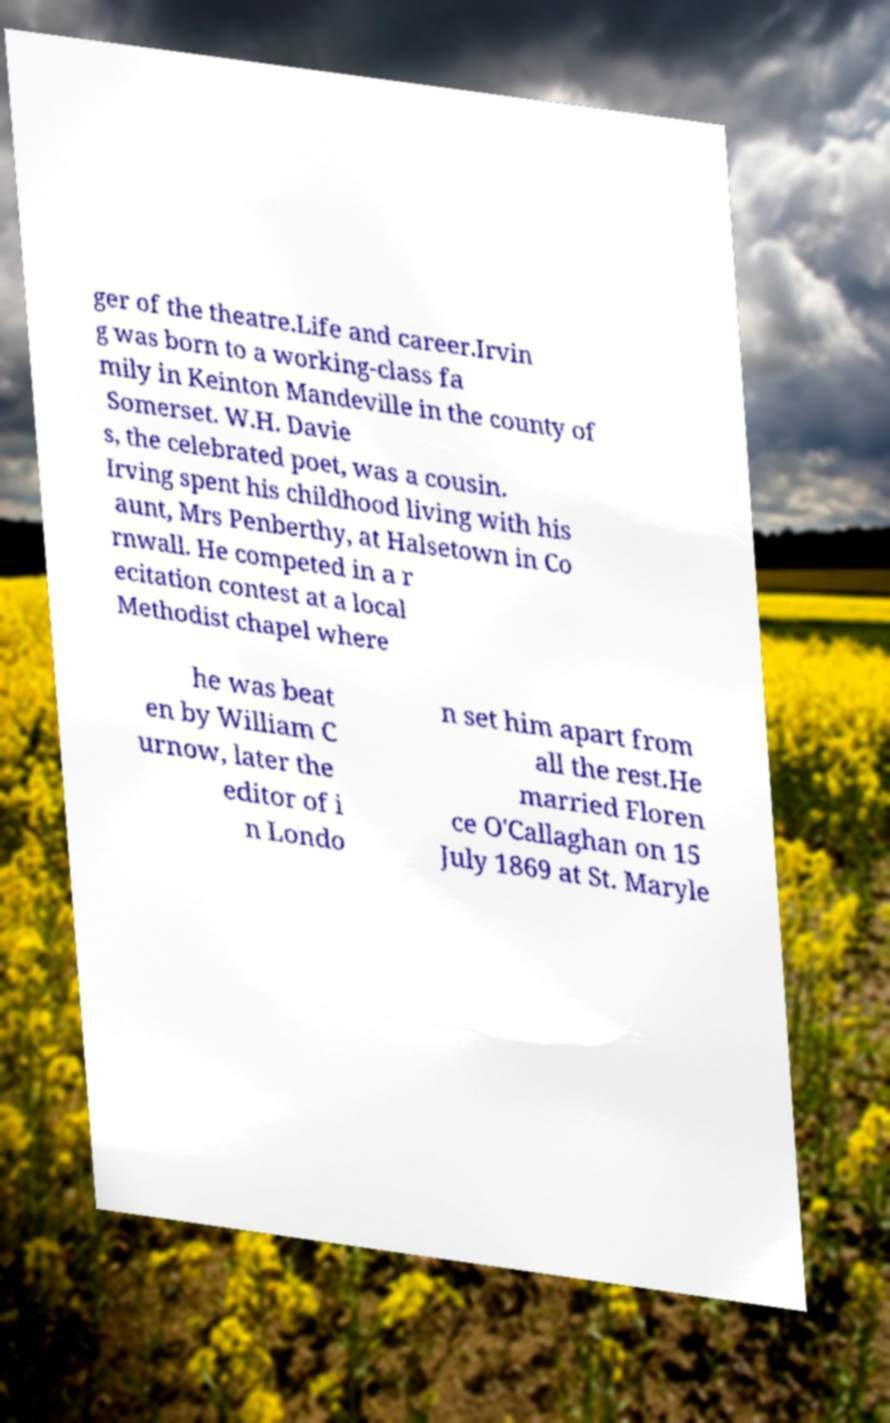There's text embedded in this image that I need extracted. Can you transcribe it verbatim? ger of the theatre.Life and career.Irvin g was born to a working-class fa mily in Keinton Mandeville in the county of Somerset. W.H. Davie s, the celebrated poet, was a cousin. Irving spent his childhood living with his aunt, Mrs Penberthy, at Halsetown in Co rnwall. He competed in a r ecitation contest at a local Methodist chapel where he was beat en by William C urnow, later the editor of i n Londo n set him apart from all the rest.He married Floren ce O'Callaghan on 15 July 1869 at St. Maryle 